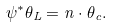<formula> <loc_0><loc_0><loc_500><loc_500>\psi ^ { * } \theta _ { L } = n \cdot \theta _ { c } .</formula> 